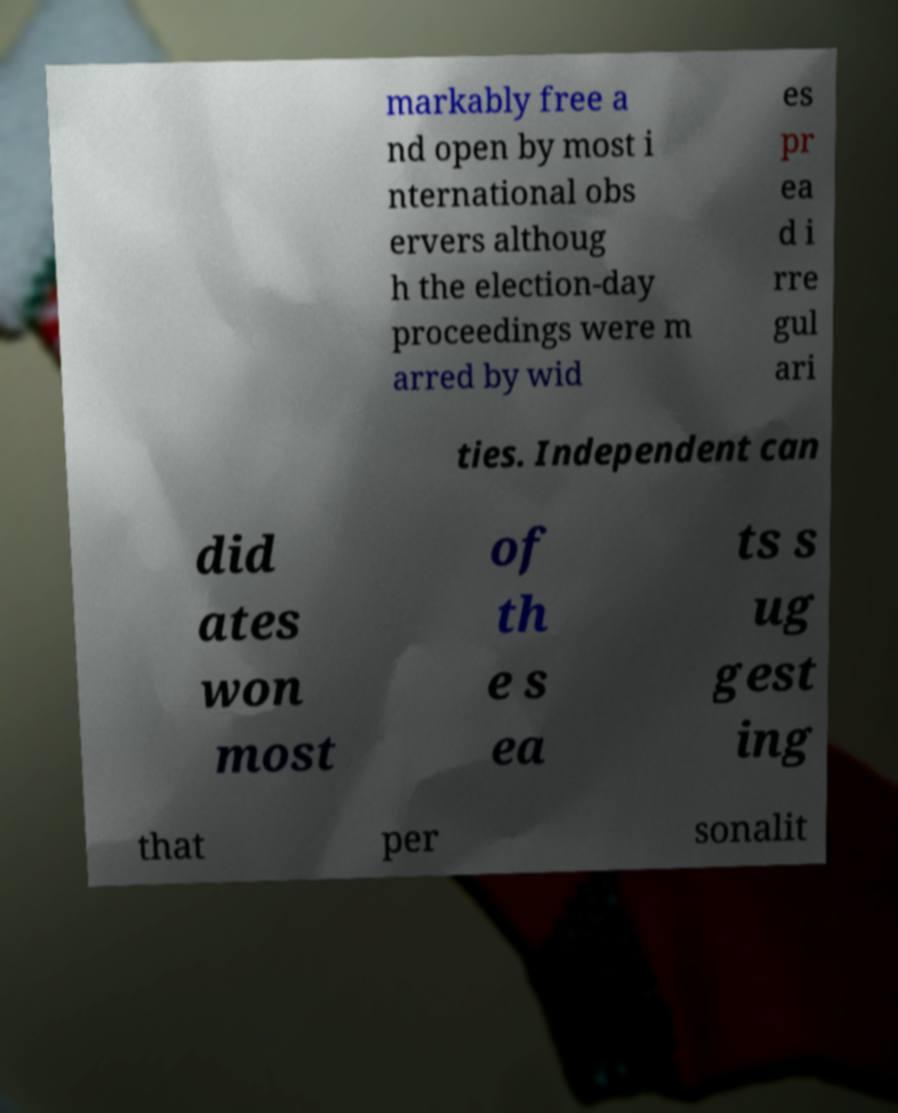What messages or text are displayed in this image? I need them in a readable, typed format. markably free a nd open by most i nternational obs ervers althoug h the election-day proceedings were m arred by wid es pr ea d i rre gul ari ties. Independent can did ates won most of th e s ea ts s ug gest ing that per sonalit 